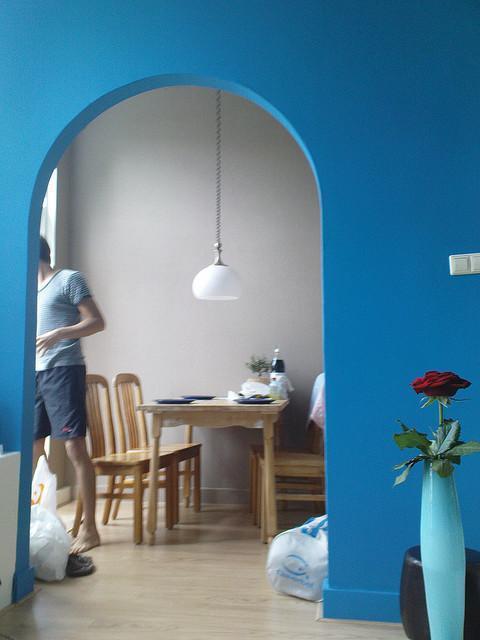What is furthest to the right?
Make your selection and explain in format: 'Answer: answer
Rationale: rationale.'
Options: Flower, elephant, cat, dog. Answer: flower.
Rationale: There is a rose in a vase. 